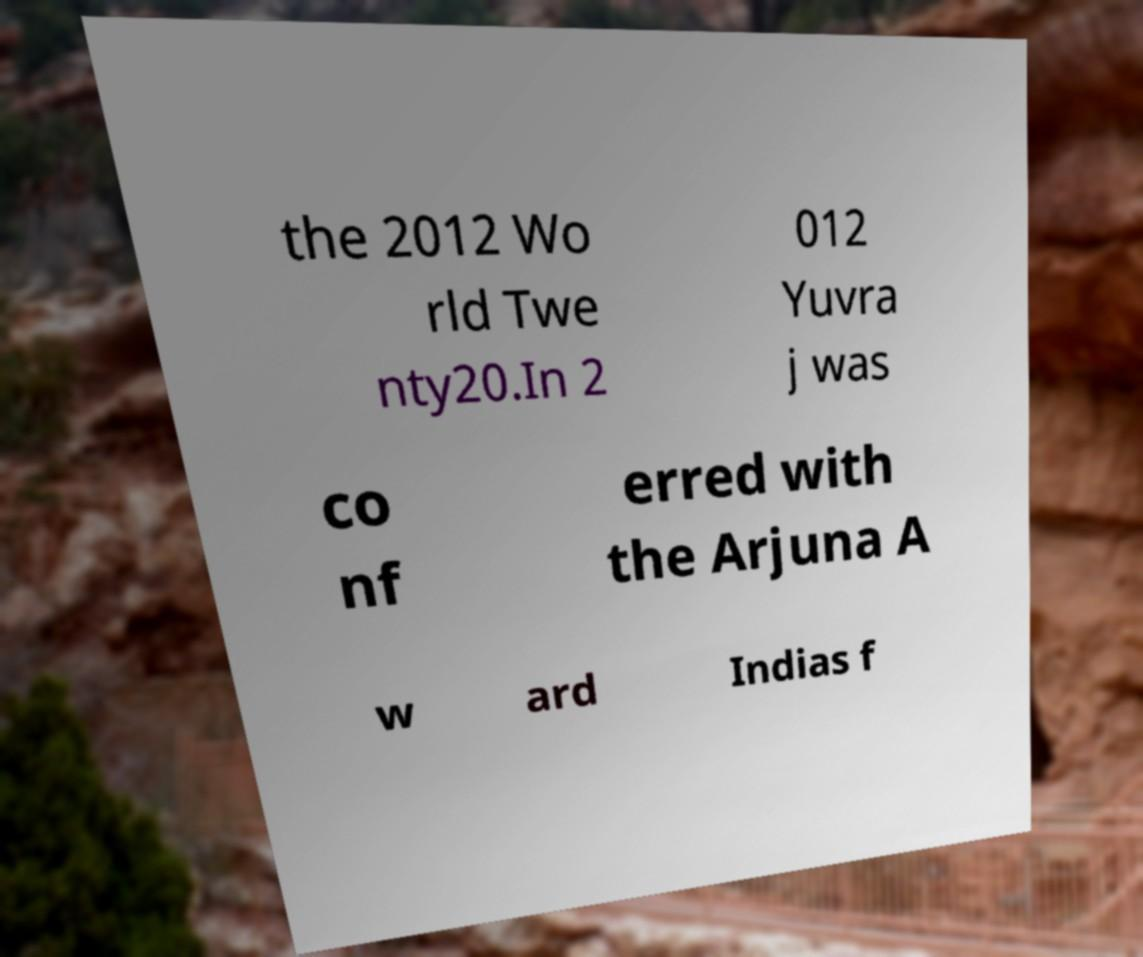Could you assist in decoding the text presented in this image and type it out clearly? the 2012 Wo rld Twe nty20.In 2 012 Yuvra j was co nf erred with the Arjuna A w ard Indias f 